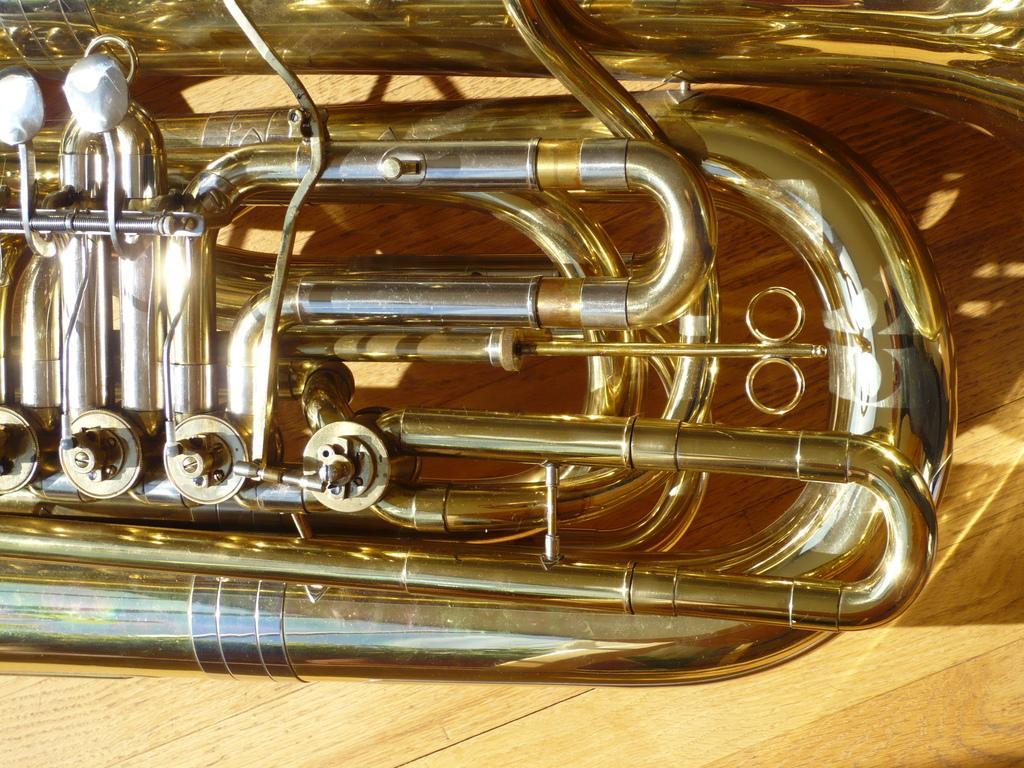Could you give a brief overview of what you see in this image? In this image we can see a trumpet placed on the table. 